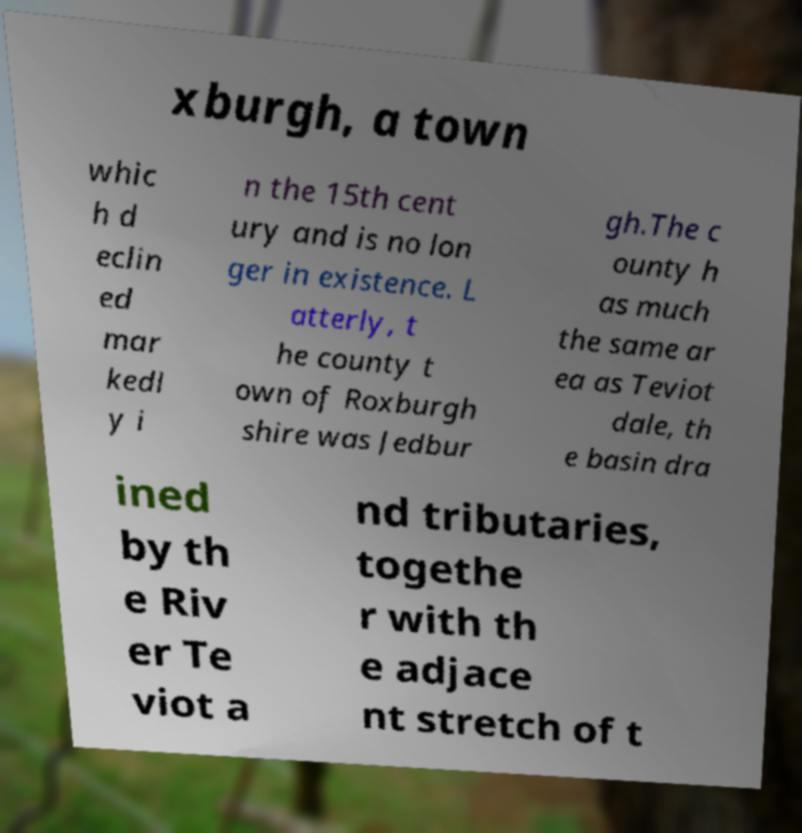Could you assist in decoding the text presented in this image and type it out clearly? xburgh, a town whic h d eclin ed mar kedl y i n the 15th cent ury and is no lon ger in existence. L atterly, t he county t own of Roxburgh shire was Jedbur gh.The c ounty h as much the same ar ea as Teviot dale, th e basin dra ined by th e Riv er Te viot a nd tributaries, togethe r with th e adjace nt stretch of t 